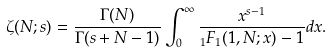<formula> <loc_0><loc_0><loc_500><loc_500>\zeta ( N ; s ) = \frac { \Gamma ( N ) } { \Gamma ( s + N - 1 ) } \int _ { 0 } ^ { \infty } \frac { x ^ { s - 1 } } { _ { 1 } F _ { 1 } ( 1 , N ; x ) - 1 } d x .</formula> 